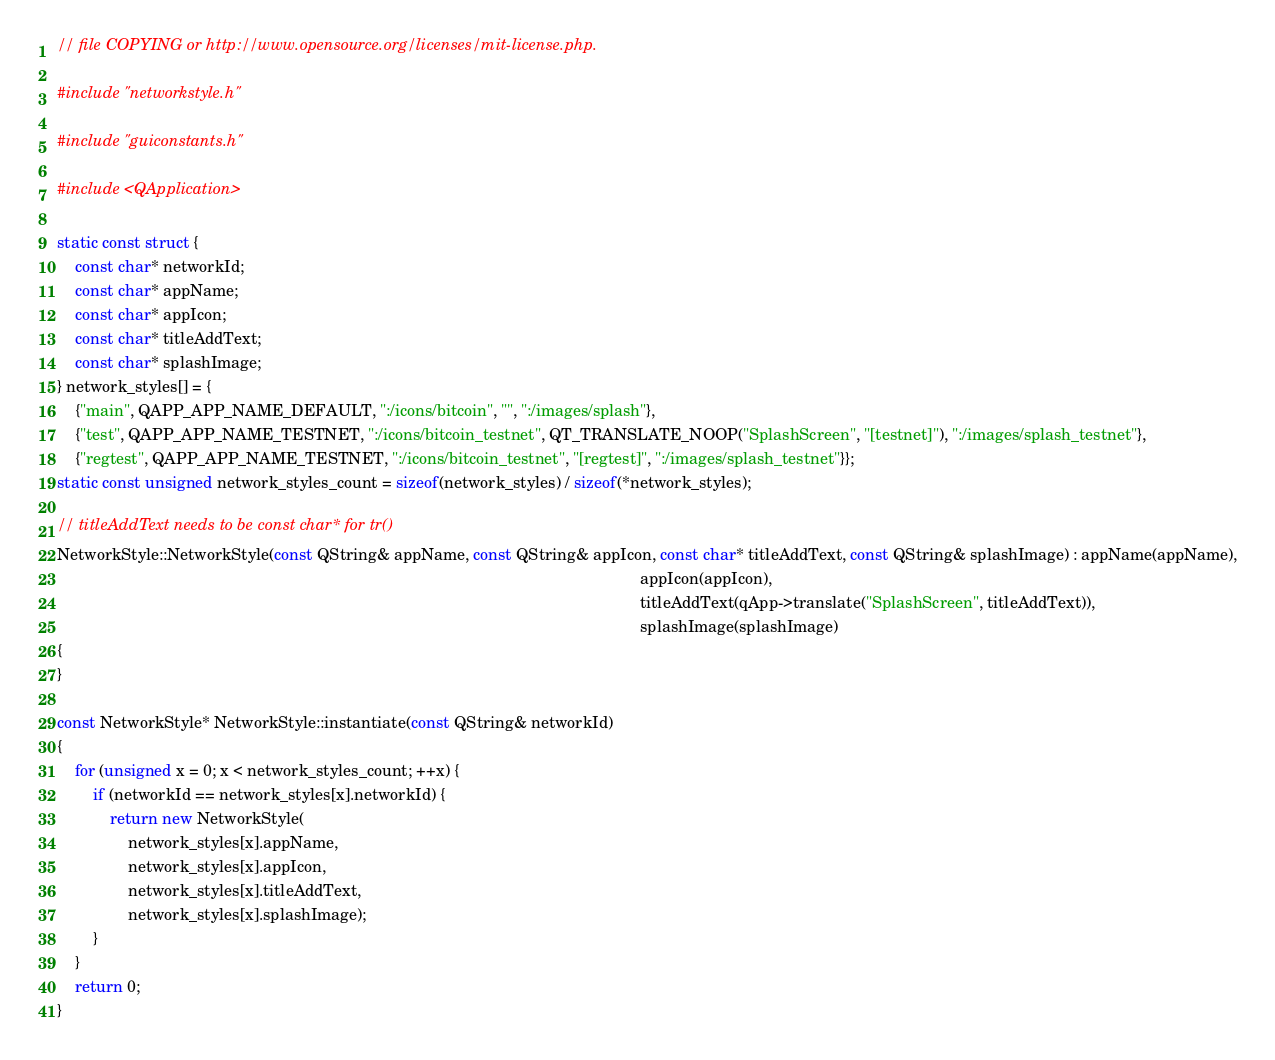Convert code to text. <code><loc_0><loc_0><loc_500><loc_500><_C++_>// file COPYING or http://www.opensource.org/licenses/mit-license.php.

#include "networkstyle.h"

#include "guiconstants.h"

#include <QApplication>

static const struct {
    const char* networkId;
    const char* appName;
    const char* appIcon;
    const char* titleAddText;
    const char* splashImage;
} network_styles[] = {
    {"main", QAPP_APP_NAME_DEFAULT, ":/icons/bitcoin", "", ":/images/splash"},
    {"test", QAPP_APP_NAME_TESTNET, ":/icons/bitcoin_testnet", QT_TRANSLATE_NOOP("SplashScreen", "[testnet]"), ":/images/splash_testnet"},
    {"regtest", QAPP_APP_NAME_TESTNET, ":/icons/bitcoin_testnet", "[regtest]", ":/images/splash_testnet"}};
static const unsigned network_styles_count = sizeof(network_styles) / sizeof(*network_styles);

// titleAddText needs to be const char* for tr()
NetworkStyle::NetworkStyle(const QString& appName, const QString& appIcon, const char* titleAddText, const QString& splashImage) : appName(appName),
                                                                                                                                   appIcon(appIcon),
                                                                                                                                   titleAddText(qApp->translate("SplashScreen", titleAddText)),
                                                                                                                                   splashImage(splashImage)
{
}

const NetworkStyle* NetworkStyle::instantiate(const QString& networkId)
{
    for (unsigned x = 0; x < network_styles_count; ++x) {
        if (networkId == network_styles[x].networkId) {
            return new NetworkStyle(
                network_styles[x].appName,
                network_styles[x].appIcon,
                network_styles[x].titleAddText,
                network_styles[x].splashImage);
        }
    }
    return 0;
}
</code> 